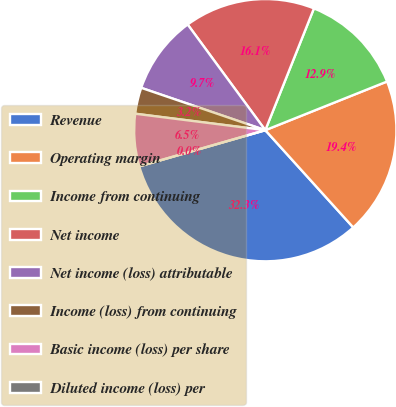<chart> <loc_0><loc_0><loc_500><loc_500><pie_chart><fcel>Revenue<fcel>Operating margin<fcel>Income from continuing<fcel>Net income<fcel>Net income (loss) attributable<fcel>Income (loss) from continuing<fcel>Basic income (loss) per share<fcel>Diluted income (loss) per<nl><fcel>32.25%<fcel>19.35%<fcel>12.9%<fcel>16.13%<fcel>9.68%<fcel>3.23%<fcel>6.45%<fcel>0.0%<nl></chart> 